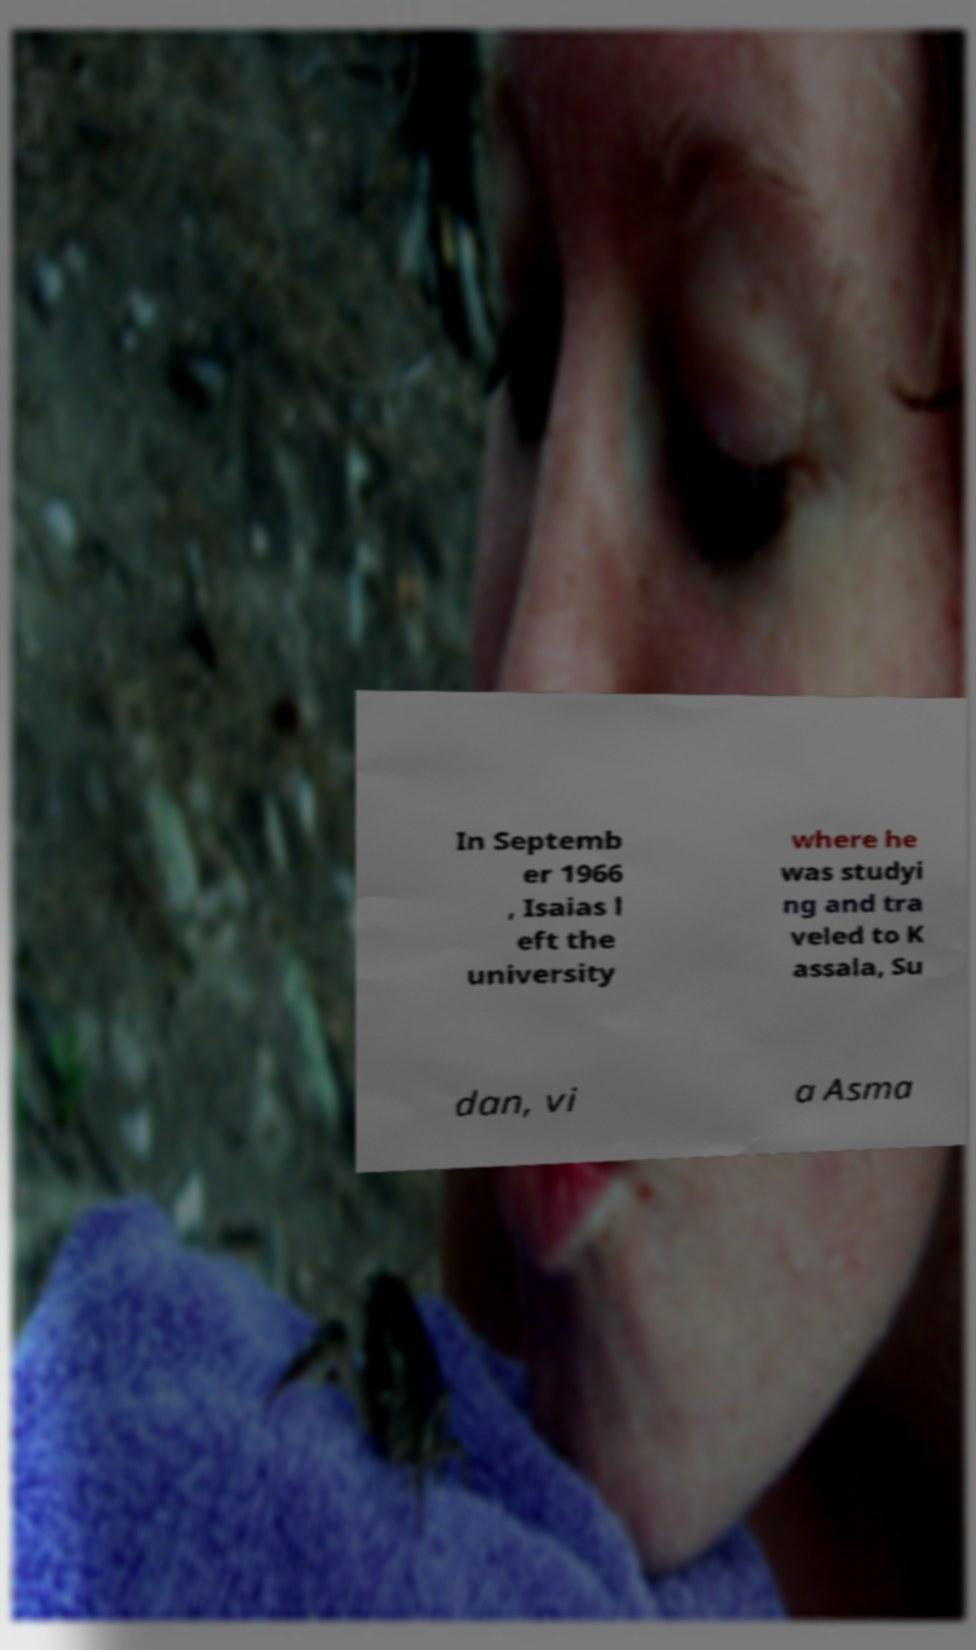Please identify and transcribe the text found in this image. In Septemb er 1966 , Isaias l eft the university where he was studyi ng and tra veled to K assala, Su dan, vi a Asma 